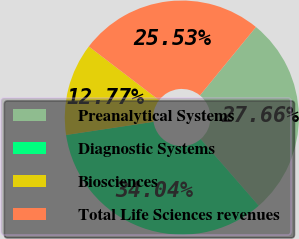Convert chart. <chart><loc_0><loc_0><loc_500><loc_500><pie_chart><fcel>Preanalytical Systems<fcel>Diagnostic Systems<fcel>Biosciences<fcel>Total Life Sciences revenues<nl><fcel>27.66%<fcel>34.04%<fcel>12.77%<fcel>25.53%<nl></chart> 